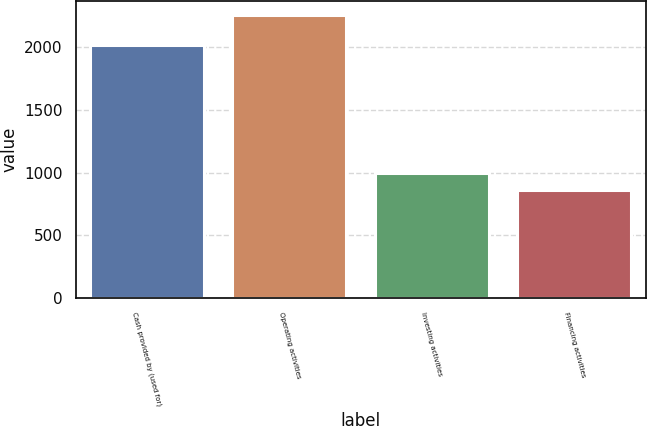Convert chart. <chart><loc_0><loc_0><loc_500><loc_500><bar_chart><fcel>Cash provided by (used for)<fcel>Operating activities<fcel>Investing activities<fcel>Financing activities<nl><fcel>2016<fcel>2258.8<fcel>1000.06<fcel>860.2<nl></chart> 